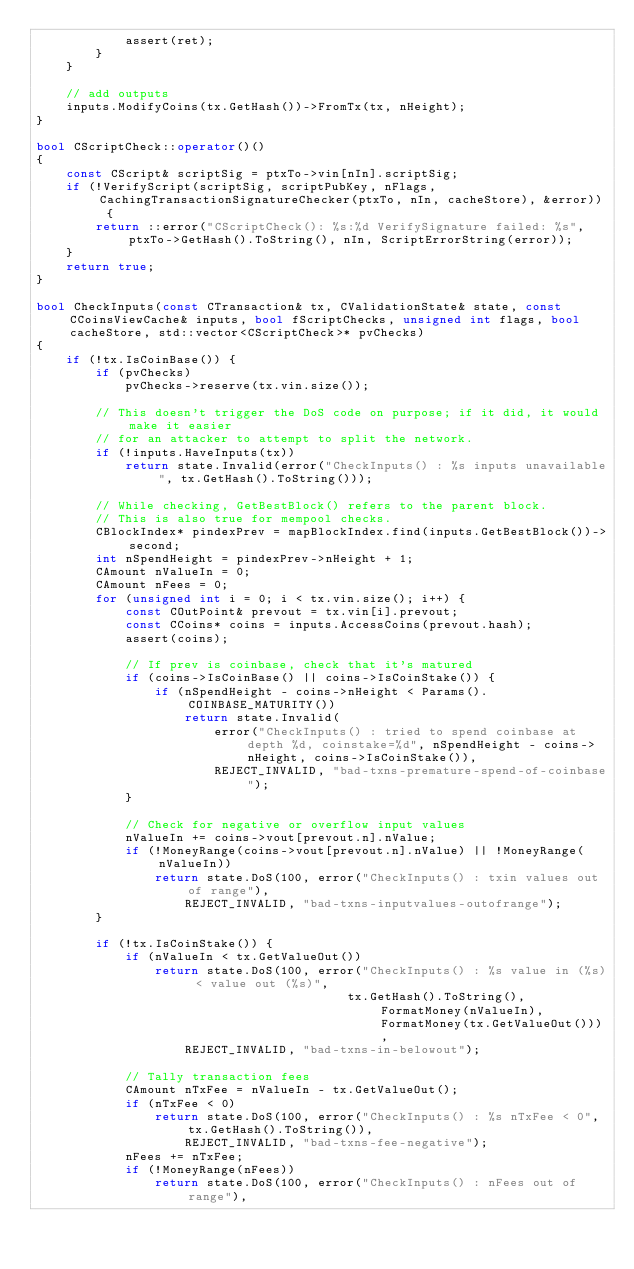Convert code to text. <code><loc_0><loc_0><loc_500><loc_500><_C++_>            assert(ret);
        }
    }

    // add outputs
    inputs.ModifyCoins(tx.GetHash())->FromTx(tx, nHeight);
}

bool CScriptCheck::operator()()
{
    const CScript& scriptSig = ptxTo->vin[nIn].scriptSig;
    if (!VerifyScript(scriptSig, scriptPubKey, nFlags, CachingTransactionSignatureChecker(ptxTo, nIn, cacheStore), &error)) {
        return ::error("CScriptCheck(): %s:%d VerifySignature failed: %s", ptxTo->GetHash().ToString(), nIn, ScriptErrorString(error));
    }
    return true;
}

bool CheckInputs(const CTransaction& tx, CValidationState& state, const CCoinsViewCache& inputs, bool fScriptChecks, unsigned int flags, bool cacheStore, std::vector<CScriptCheck>* pvChecks)
{
    if (!tx.IsCoinBase()) {
        if (pvChecks)
            pvChecks->reserve(tx.vin.size());

        // This doesn't trigger the DoS code on purpose; if it did, it would make it easier
        // for an attacker to attempt to split the network.
        if (!inputs.HaveInputs(tx))
            return state.Invalid(error("CheckInputs() : %s inputs unavailable", tx.GetHash().ToString()));

        // While checking, GetBestBlock() refers to the parent block.
        // This is also true for mempool checks.
        CBlockIndex* pindexPrev = mapBlockIndex.find(inputs.GetBestBlock())->second;
        int nSpendHeight = pindexPrev->nHeight + 1;
        CAmount nValueIn = 0;
        CAmount nFees = 0;
        for (unsigned int i = 0; i < tx.vin.size(); i++) {
            const COutPoint& prevout = tx.vin[i].prevout;
            const CCoins* coins = inputs.AccessCoins(prevout.hash);
            assert(coins);

            // If prev is coinbase, check that it's matured
            if (coins->IsCoinBase() || coins->IsCoinStake()) {
                if (nSpendHeight - coins->nHeight < Params().COINBASE_MATURITY())
                    return state.Invalid(
                        error("CheckInputs() : tried to spend coinbase at depth %d, coinstake=%d", nSpendHeight - coins->nHeight, coins->IsCoinStake()),
                        REJECT_INVALID, "bad-txns-premature-spend-of-coinbase");
            }

            // Check for negative or overflow input values
            nValueIn += coins->vout[prevout.n].nValue;
            if (!MoneyRange(coins->vout[prevout.n].nValue) || !MoneyRange(nValueIn))
                return state.DoS(100, error("CheckInputs() : txin values out of range"),
                    REJECT_INVALID, "bad-txns-inputvalues-outofrange");
        }

        if (!tx.IsCoinStake()) {
            if (nValueIn < tx.GetValueOut())
                return state.DoS(100, error("CheckInputs() : %s value in (%s) < value out (%s)",
                                          tx.GetHash().ToString(), FormatMoney(nValueIn), FormatMoney(tx.GetValueOut())),
                    REJECT_INVALID, "bad-txns-in-belowout");

            // Tally transaction fees
            CAmount nTxFee = nValueIn - tx.GetValueOut();
            if (nTxFee < 0)
                return state.DoS(100, error("CheckInputs() : %s nTxFee < 0", tx.GetHash().ToString()),
                    REJECT_INVALID, "bad-txns-fee-negative");
            nFees += nTxFee;
            if (!MoneyRange(nFees))
                return state.DoS(100, error("CheckInputs() : nFees out of range"),</code> 